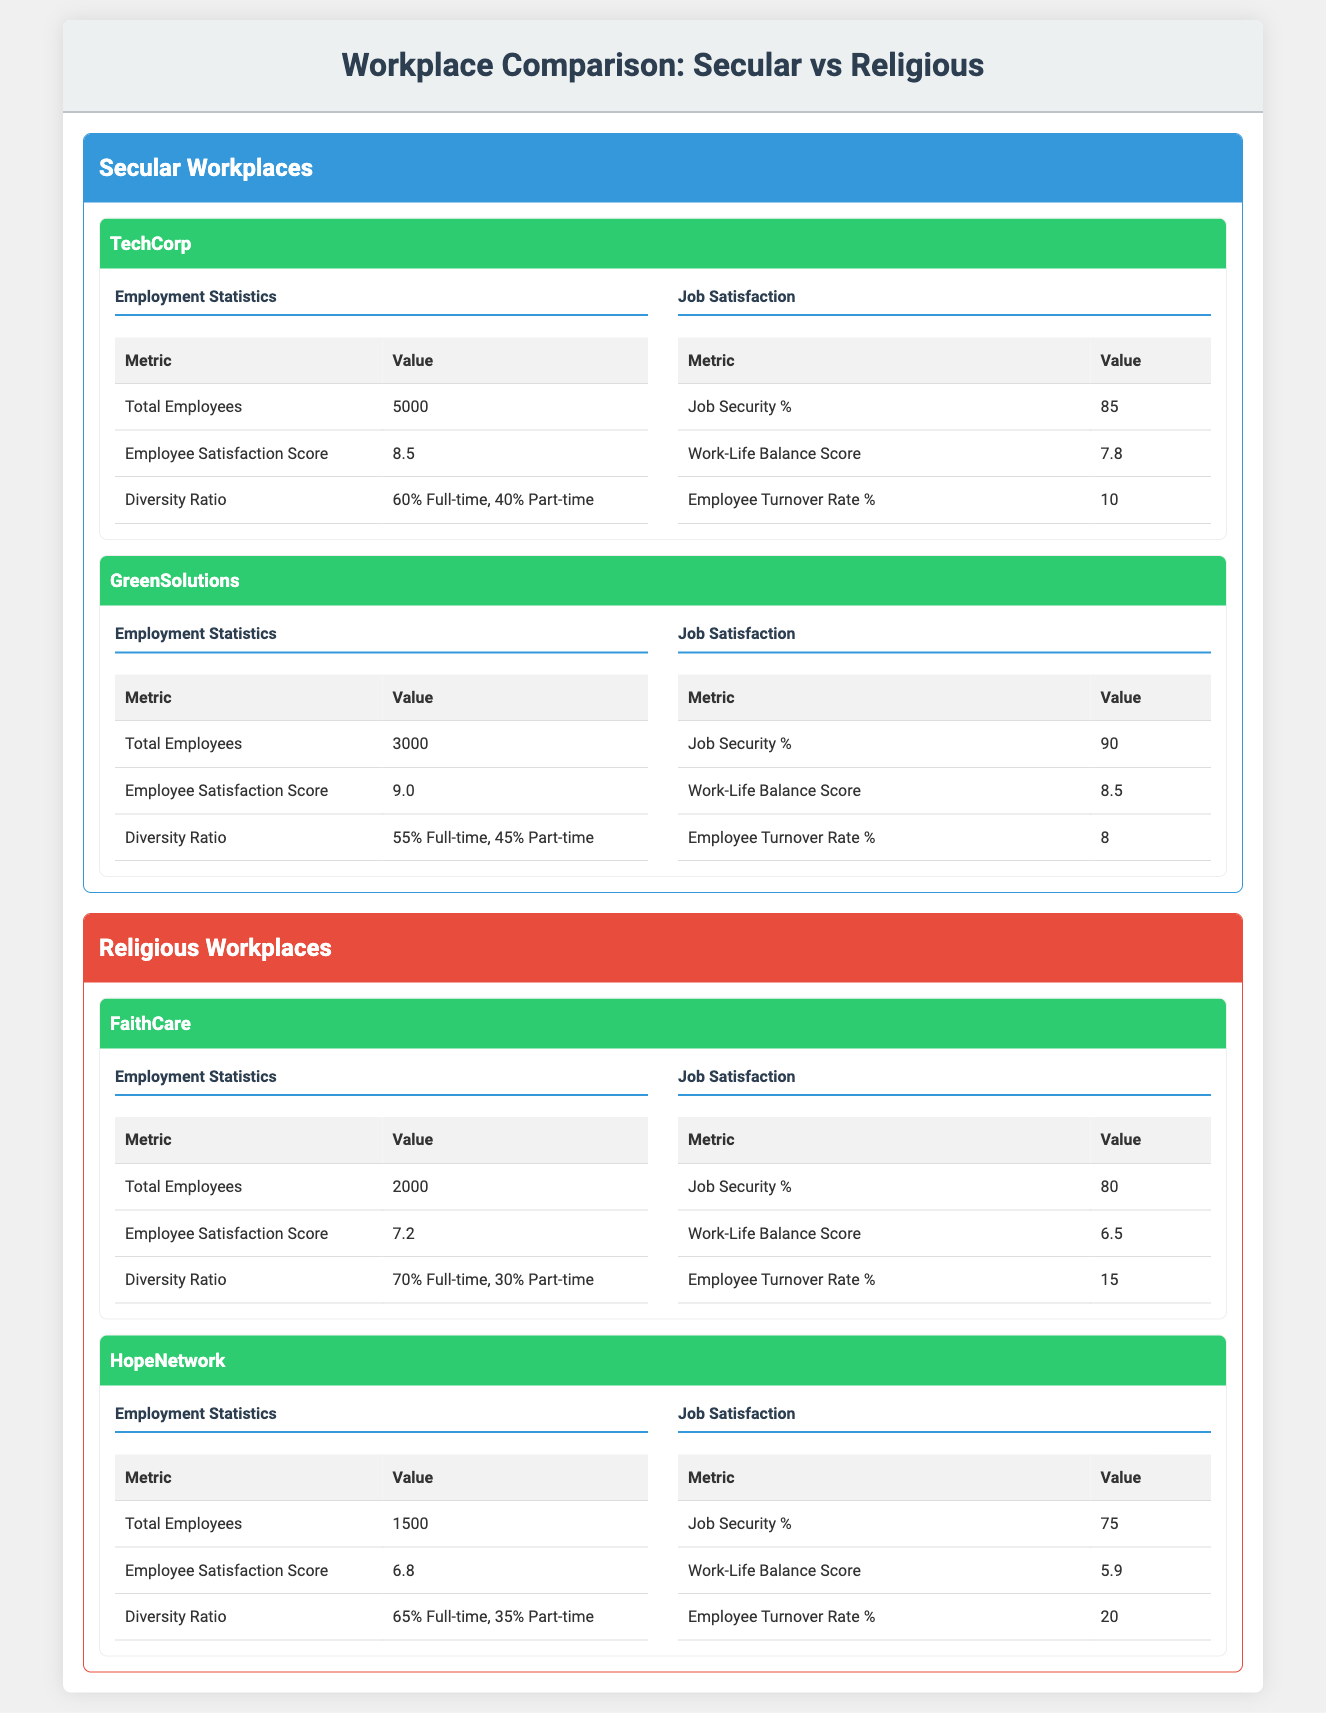What is the employee satisfaction score for TechCorp? The employee satisfaction score for TechCorp is provided in the Employment Statistics section. It is directly stated as 8.5.
Answer: 8.5 What is the total number of employees in FaithCare? The total number of employees in FaithCare is listed under Employment Statistics. It states that there are 2000 employees.
Answer: 2000 Which secular workplace has a higher work-life balance score, TechCorp or GreenSolutions? TechCorp has a work-life balance score of 7.8, while GreenSolutions has a score of 8.5. Since 8.5 is greater than 7.8, GreenSolutions has a higher score.
Answer: GreenSolutions What is the difference in job security percentage between HopeNetwork and GreenSolutions? HopeNetwork has a job security percentage of 75%, and GreenSolutions has 90%. To find the difference, subtract 75 from 90, which equals 15.
Answer: 15 Is the employee turnover rate higher in religious workplaces compared to secular workplaces? The employee turnover rates are 10% for TechCorp and 8% for GreenSolutions (secular), and 15% for FaithCare and 20% for HopeNetwork (religious). The average for religious workplaces is (15 + 20)/2 = 17.5%, while for secular workplaces it is (10 + 8)/2 = 9%. Since 17.5% is greater than 9%, the statement is true.
Answer: Yes Which secular workplace has the highest employee satisfaction score? The employee satisfaction scores are 8.5 for TechCorp and 9.0 for GreenSolutions. Since 9.0 is greater than 8.5, GreenSolutions has the highest score among secular workplaces.
Answer: GreenSolutions What is the average number of total employees in secular workplaces? The total employees for TechCorp is 5000, and for GreenSolutions, it is 3000. The average is calculated as (5000 + 3000) / 2 = 4000.
Answer: 4000 Is the diversity ratio in FaithCare higher than in TechCorp? The diversity ratio in FaithCare is 70% Full-time, 30% Part-time, while TechCorp's ratio is 60% Full-time and 40% Part-time. Since 70% is greater than 60%, this statement is true.
Answer: Yes What is the overall employee turnover rate percentage for secular workplaces? The employee turnover rates are 10% for TechCorp and 8% for GreenSolutions. The average turnover rate is (10 + 8) / 2 = 9%.
Answer: 9% 